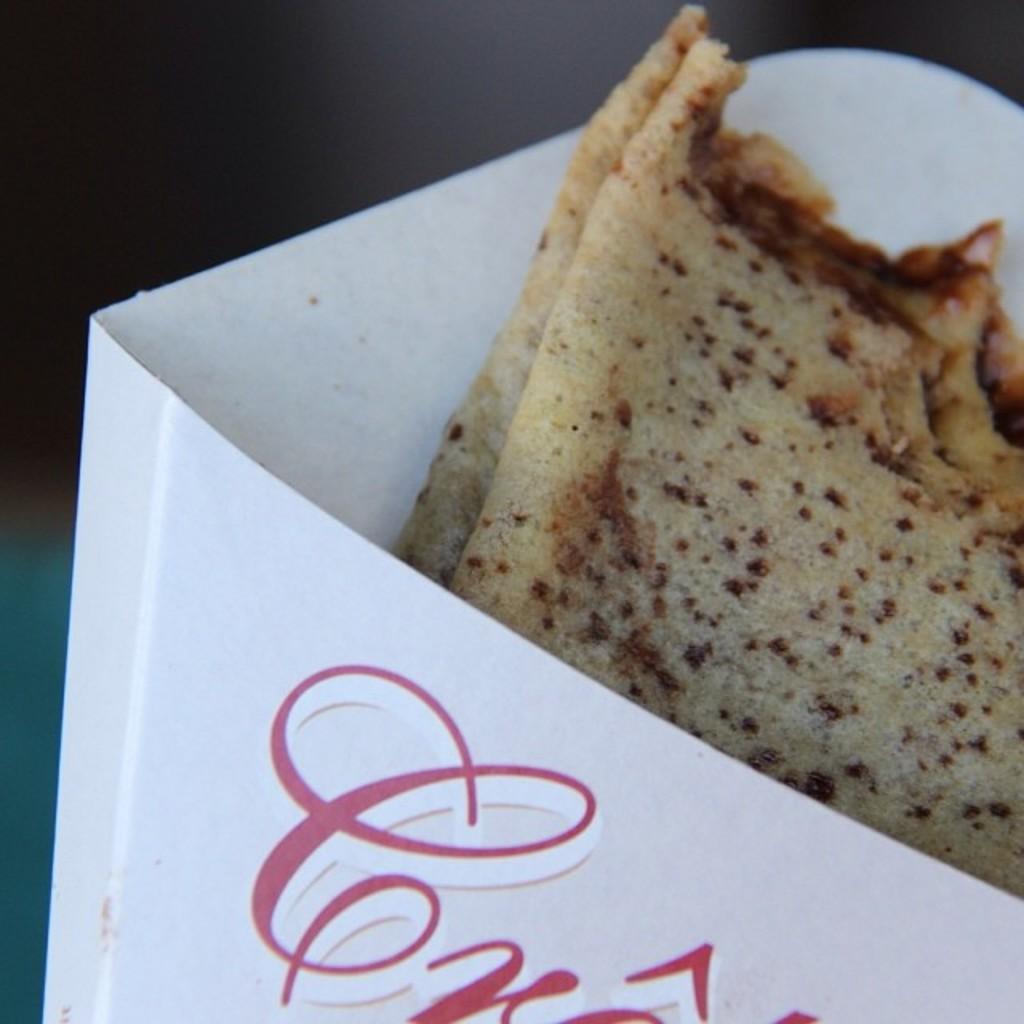Could you give a brief overview of what you see in this image? In this image I can see a paper box and in it I can see food. On the bottom side of this image I can see something is written on the box and I can see this image is little bit blurry in the background. 